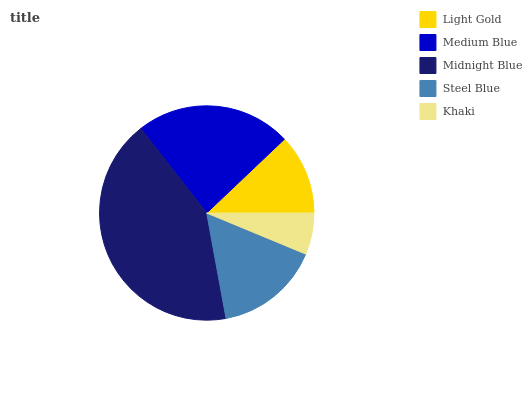Is Khaki the minimum?
Answer yes or no. Yes. Is Midnight Blue the maximum?
Answer yes or no. Yes. Is Medium Blue the minimum?
Answer yes or no. No. Is Medium Blue the maximum?
Answer yes or no. No. Is Medium Blue greater than Light Gold?
Answer yes or no. Yes. Is Light Gold less than Medium Blue?
Answer yes or no. Yes. Is Light Gold greater than Medium Blue?
Answer yes or no. No. Is Medium Blue less than Light Gold?
Answer yes or no. No. Is Steel Blue the high median?
Answer yes or no. Yes. Is Steel Blue the low median?
Answer yes or no. Yes. Is Midnight Blue the high median?
Answer yes or no. No. Is Midnight Blue the low median?
Answer yes or no. No. 